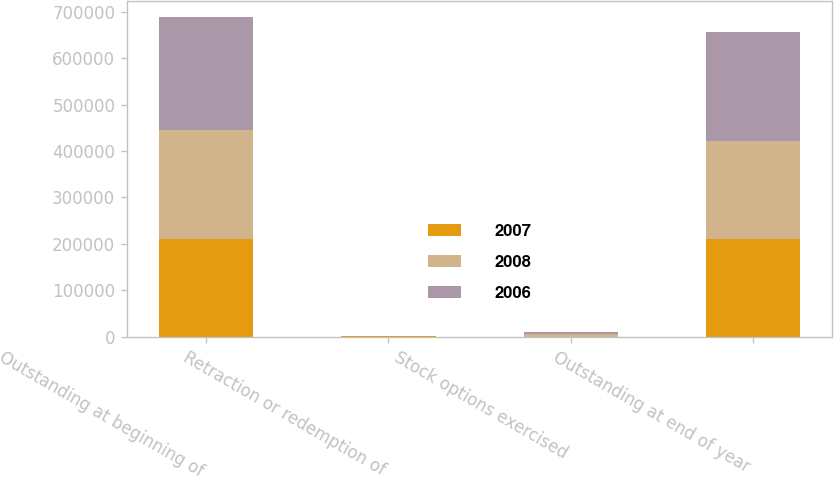Convert chart to OTSL. <chart><loc_0><loc_0><loc_500><loc_500><stacked_bar_chart><ecel><fcel>Outstanding at beginning of<fcel>Retraction or redemption of<fcel>Stock options exercised<fcel>Outstanding at end of year<nl><fcel>2007<fcel>209546<fcel>1585<fcel>68<fcel>211289<nl><fcel>2008<fcel>236020<fcel>388<fcel>5577<fcel>209546<nl><fcel>2006<fcel>243138<fcel>57<fcel>3651<fcel>236020<nl></chart> 